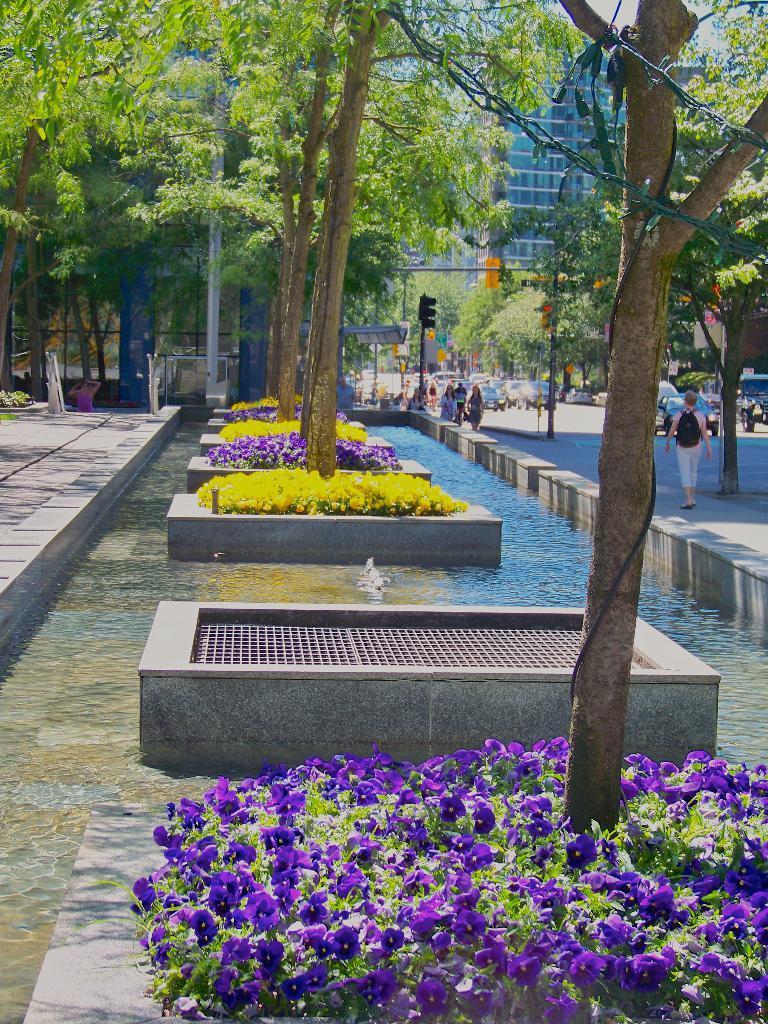Can you describe this image briefly? This image consists of many trees and plants. We can see colorful flowers in this image. On the right, there is water. And many people walking on the road. In the background, we can see many cars and buildings. 